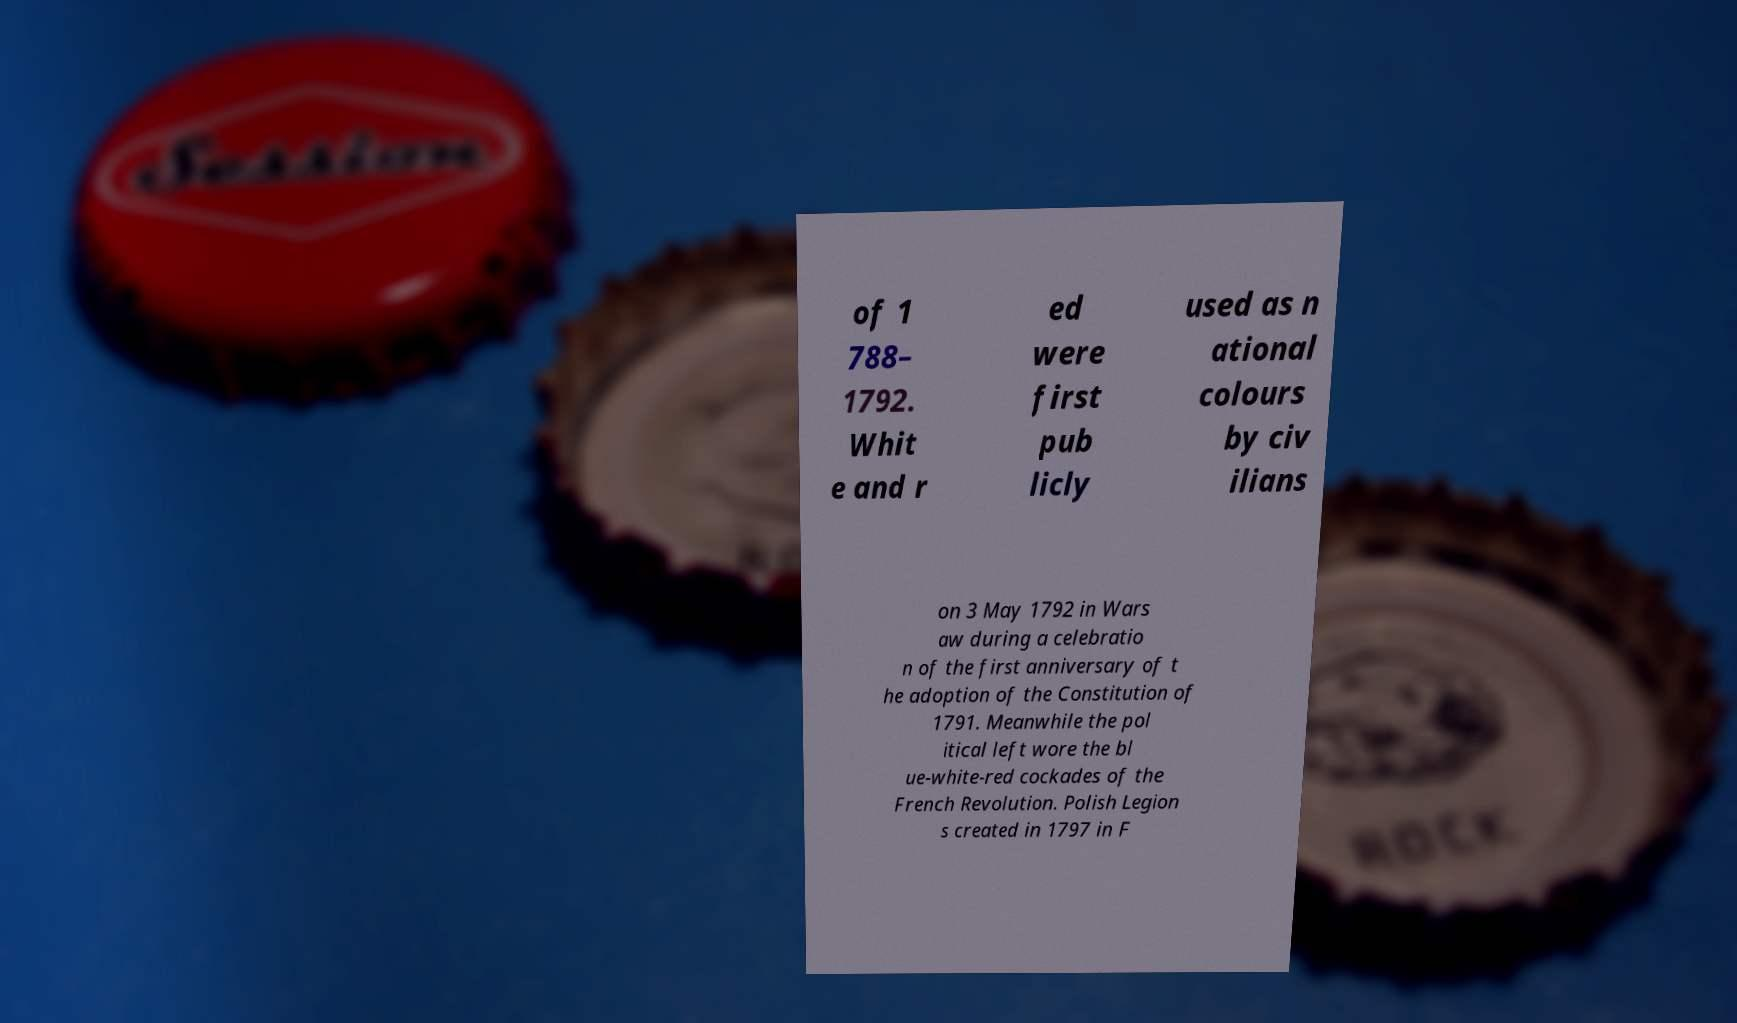Can you read and provide the text displayed in the image?This photo seems to have some interesting text. Can you extract and type it out for me? of 1 788– 1792. Whit e and r ed were first pub licly used as n ational colours by civ ilians on 3 May 1792 in Wars aw during a celebratio n of the first anniversary of t he adoption of the Constitution of 1791. Meanwhile the pol itical left wore the bl ue-white-red cockades of the French Revolution. Polish Legion s created in 1797 in F 